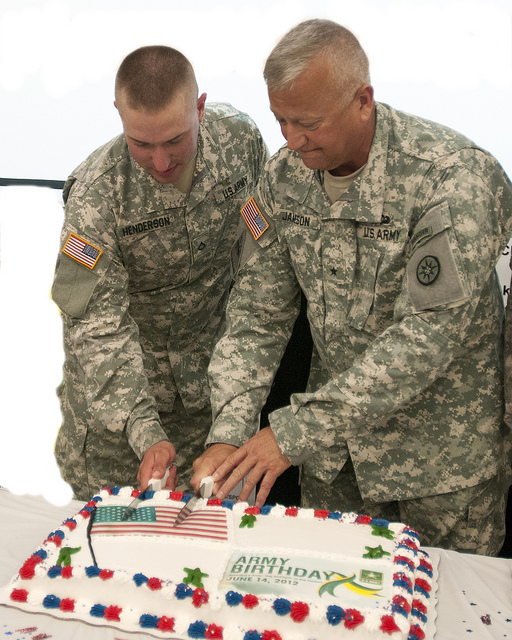Extract all visible text content from this image. HENDERSON US ARMY JANSON US ARMY AEMY BIRTHDAY 